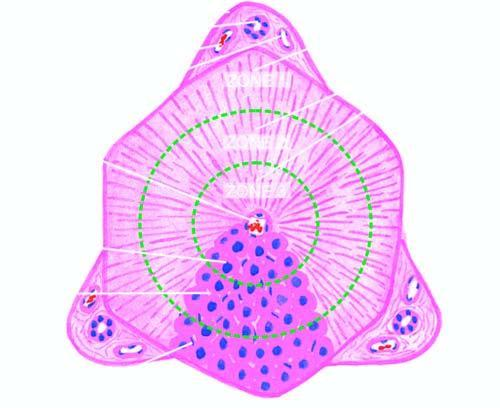what are shown by circles?
Answer the question using a single word or phrase. Functional divisions of the lobule into 3 zones 